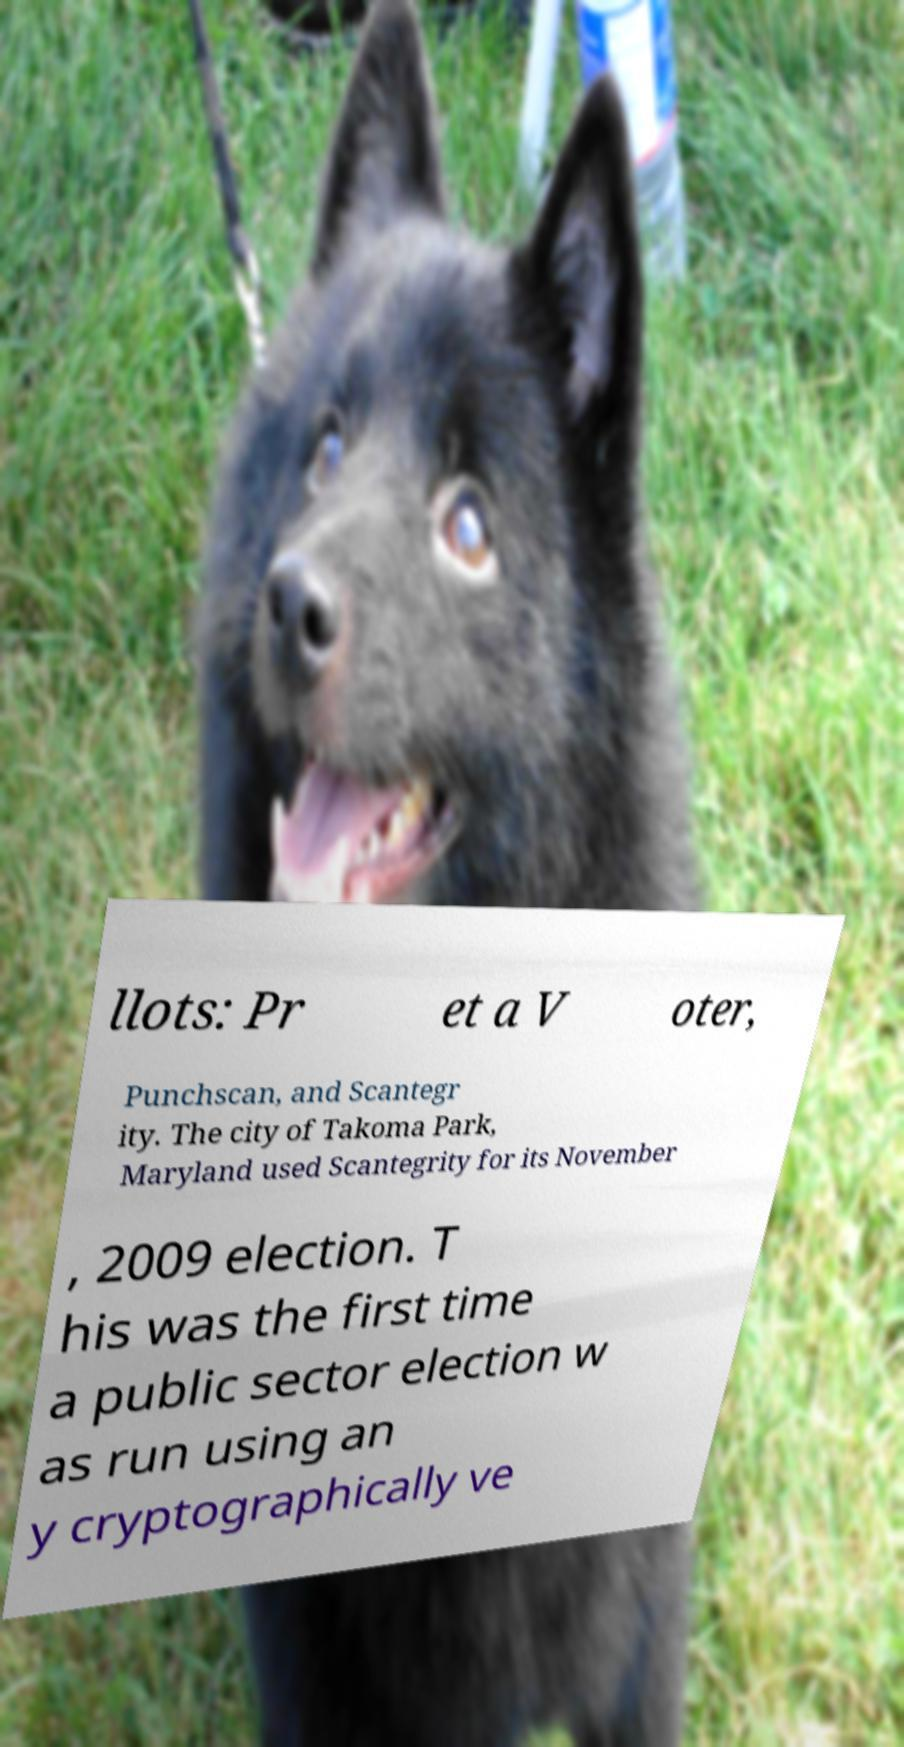Can you read and provide the text displayed in the image?This photo seems to have some interesting text. Can you extract and type it out for me? llots: Pr et a V oter, Punchscan, and Scantegr ity. The city of Takoma Park, Maryland used Scantegrity for its November , 2009 election. T his was the first time a public sector election w as run using an y cryptographically ve 